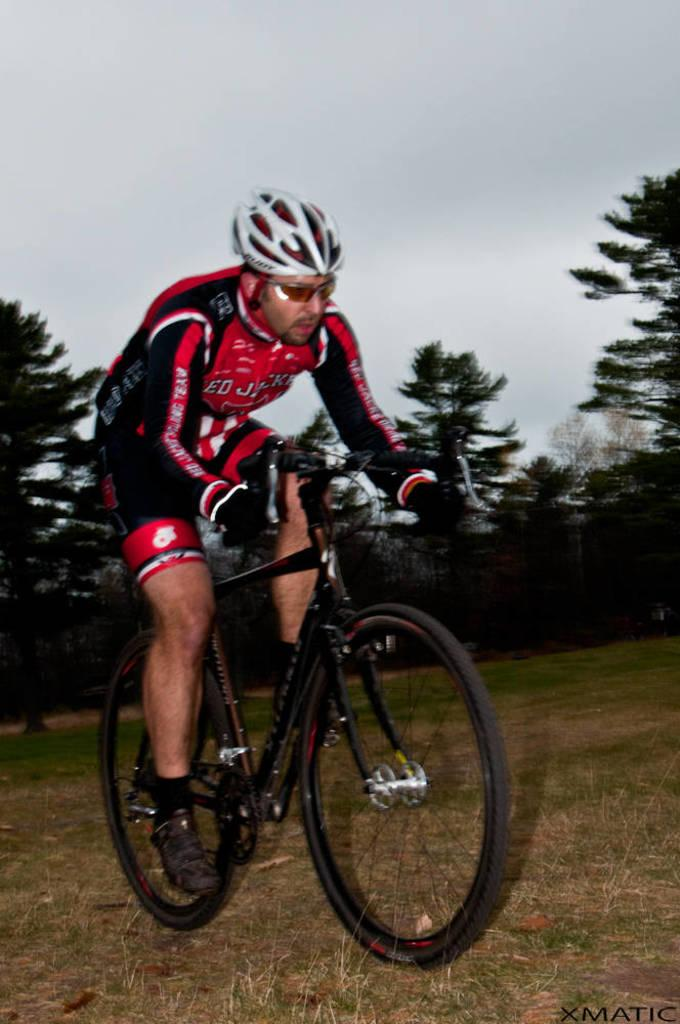Who is the main subject in the image? There is a man in the image. What is the man doing in the image? The man is riding a bicycle. What can be seen in the background of the image? There are trees and the sky visible in the background of the image. What type of vase can be seen on the man's head in the image? There is no vase present on the man's head in the image. Can you describe the owl that is perched on the bicycle in the image? There is no owl present on the bicycle in the image. 